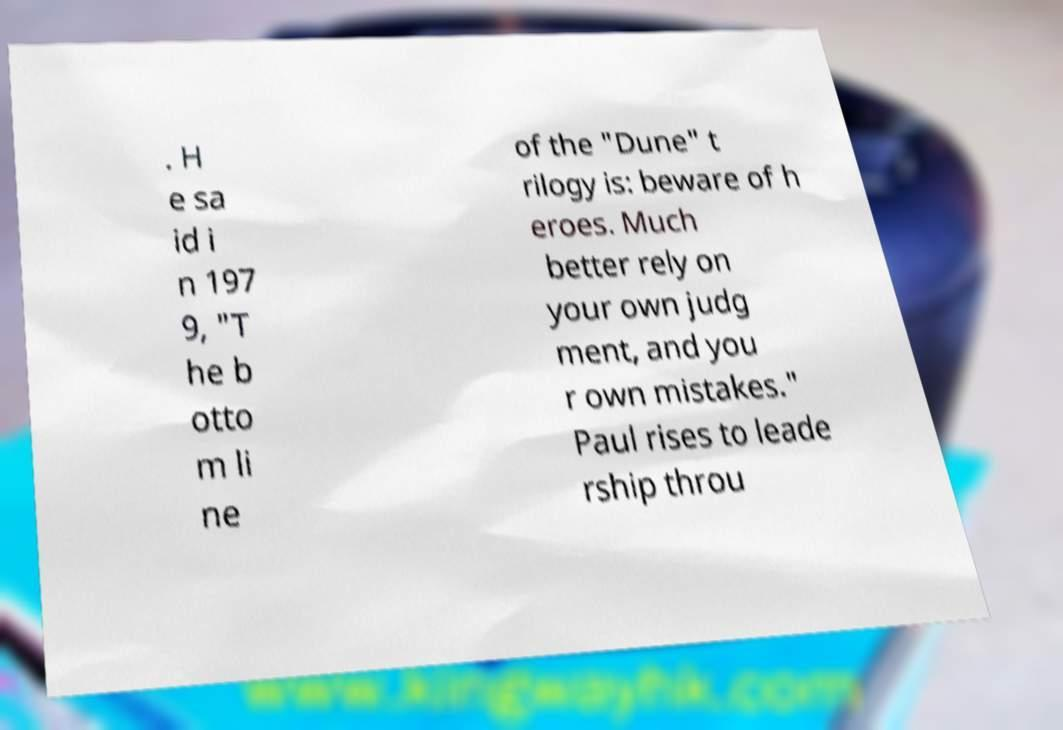Can you read and provide the text displayed in the image?This photo seems to have some interesting text. Can you extract and type it out for me? . H e sa id i n 197 9, "T he b otto m li ne of the "Dune" t rilogy is: beware of h eroes. Much better rely on your own judg ment, and you r own mistakes." Paul rises to leade rship throu 